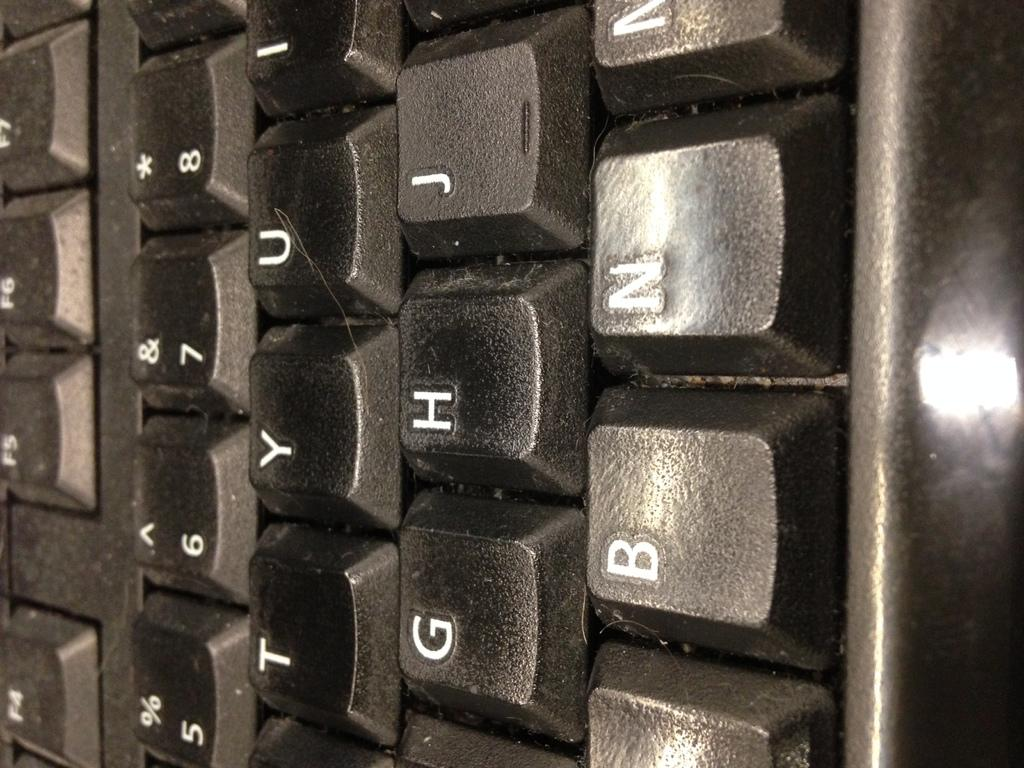Provide a one-sentence caption for the provided image. A keyboard's G, H, B and N keys are seen close up. 